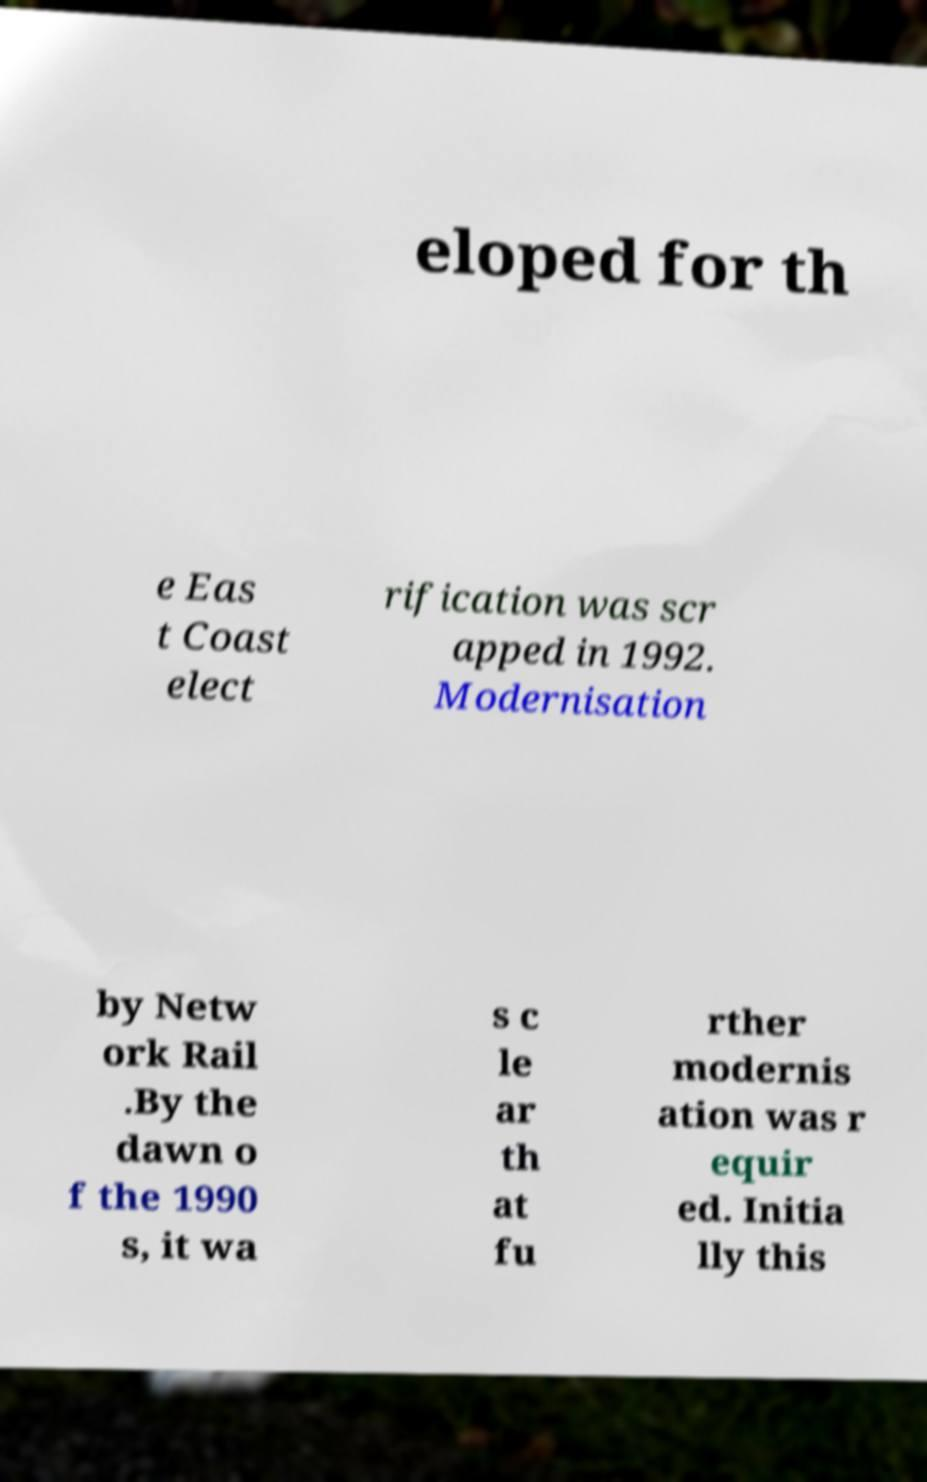Could you assist in decoding the text presented in this image and type it out clearly? eloped for th e Eas t Coast elect rification was scr apped in 1992. Modernisation by Netw ork Rail .By the dawn o f the 1990 s, it wa s c le ar th at fu rther modernis ation was r equir ed. Initia lly this 